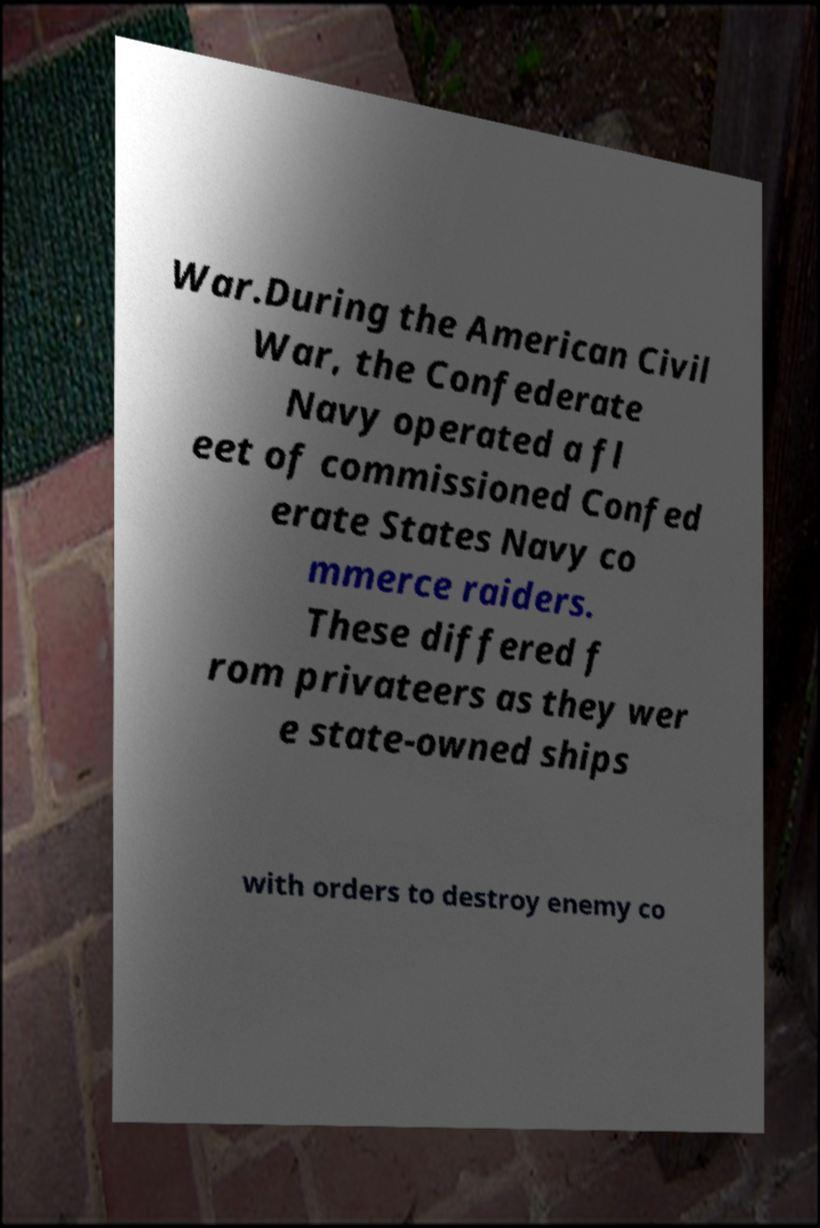Please read and relay the text visible in this image. What does it say? War.During the American Civil War, the Confederate Navy operated a fl eet of commissioned Confed erate States Navy co mmerce raiders. These differed f rom privateers as they wer e state-owned ships with orders to destroy enemy co 